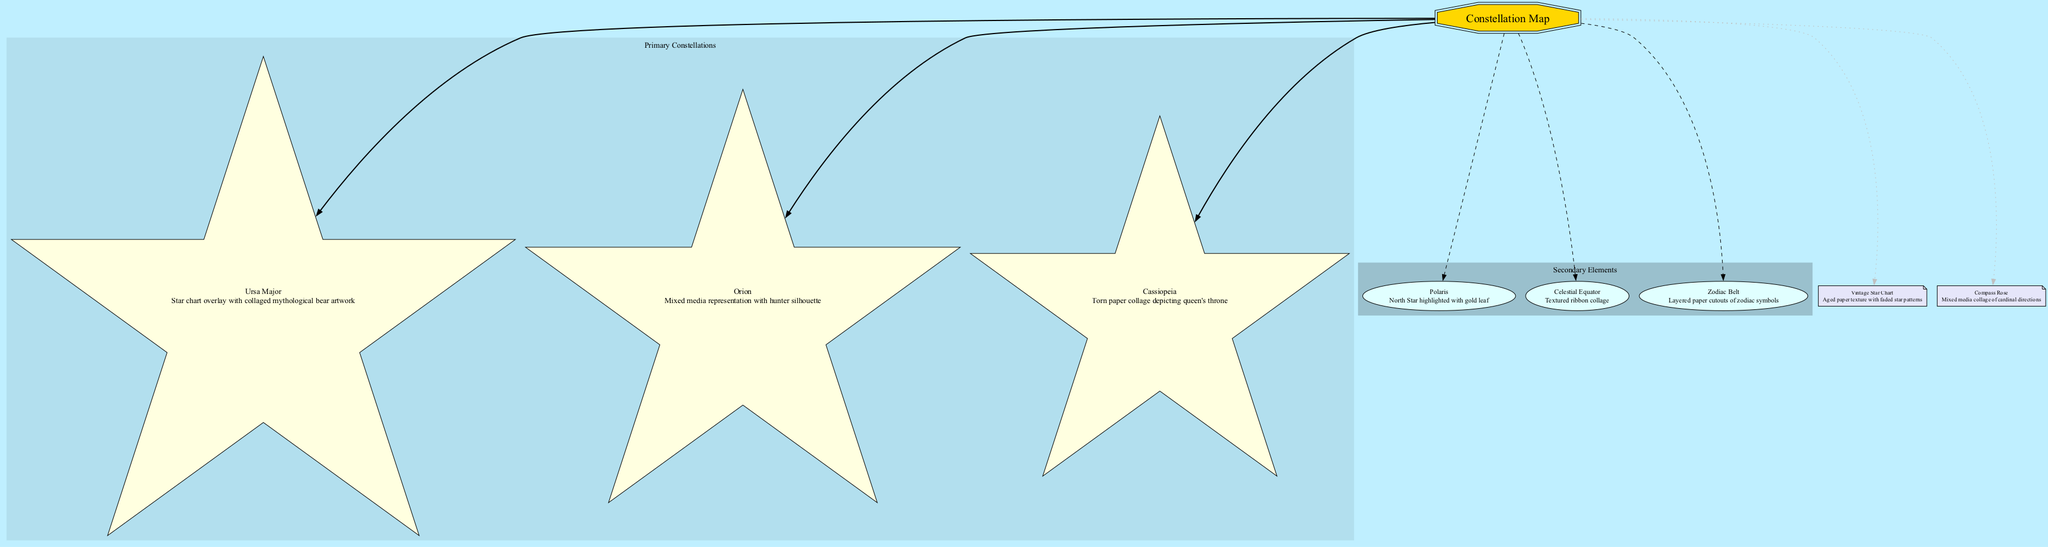What are the three primary constellations illustrated in the diagram? The diagram lists Ursa Major, Orion, and Cassiopeia as the primary constellations. These are directly mentioned as part of the primary elements in the diagram.
Answer: Ursa Major, Orion, Cassiopeia Which star is highlighted with gold leaf? The diagram identifies Polaris as the North Star, and it specifies that it is highlighted with gold leaf among the secondary elements.
Answer: Polaris How many primary constellations are represented in the diagram? By reviewing the primary elements section of the diagram, it shows three distinct constellations, which are Ursa Major, Orion, and Cassiopeia.
Answer: 3 What is the description of the secondary element 'Zodiac Belt'? The Zodiac Belt is described as "Layered paper cutouts of zodiac symbols," which can be found under the secondary elements in the diagram.
Answer: Layered paper cutouts of zodiac symbols What type of collage technique is used for Cassiopeia? The diagram states that Cassiopeia is represented by a "Torn paper collage depicting queen's throne," emphasizing the specific collage method utilized for this constellation.
Answer: Torn paper collage Which decorative element serves as an orientation guide? The diagram indicates that the Compass Rose is the element serving as an orientation guide, specifically categorized under decorative elements.
Answer: Compass Rose How is the Celestial Equator represented in the diagram? The Celestial Equator is represented as a "Textured ribbon collage," which is noted in the details of the secondary elements of the diagram.
Answer: Textured ribbon collage What is the background texture of the vintage star chart? According to the diagram, the vintage star chart features "Aged paper texture with faded star patterns," which defines its background style.
Answer: Aged paper texture with faded star patterns Which constellation features a mixed media representation with a hunter silhouette? The description for Orion explicitly states that it is a "Mixed media representation with hunter silhouette" within the section dedicated to primary elements.
Answer: Orion 